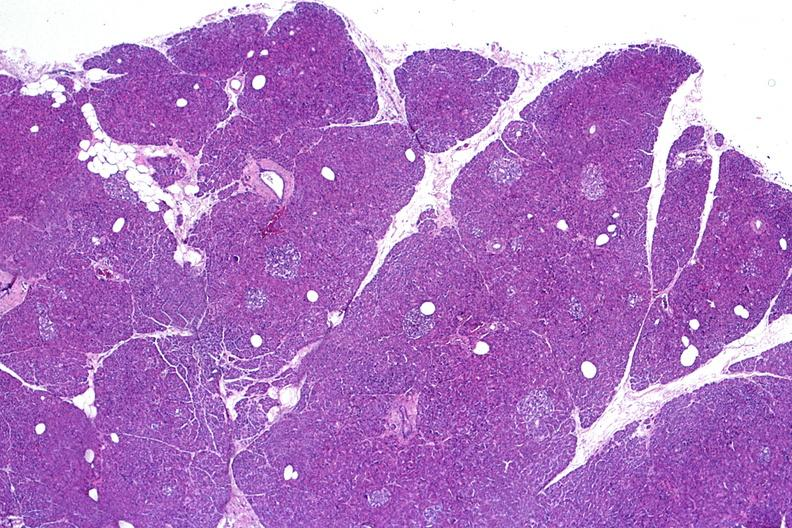where is this?
Answer the question using a single word or phrase. Pancreas 